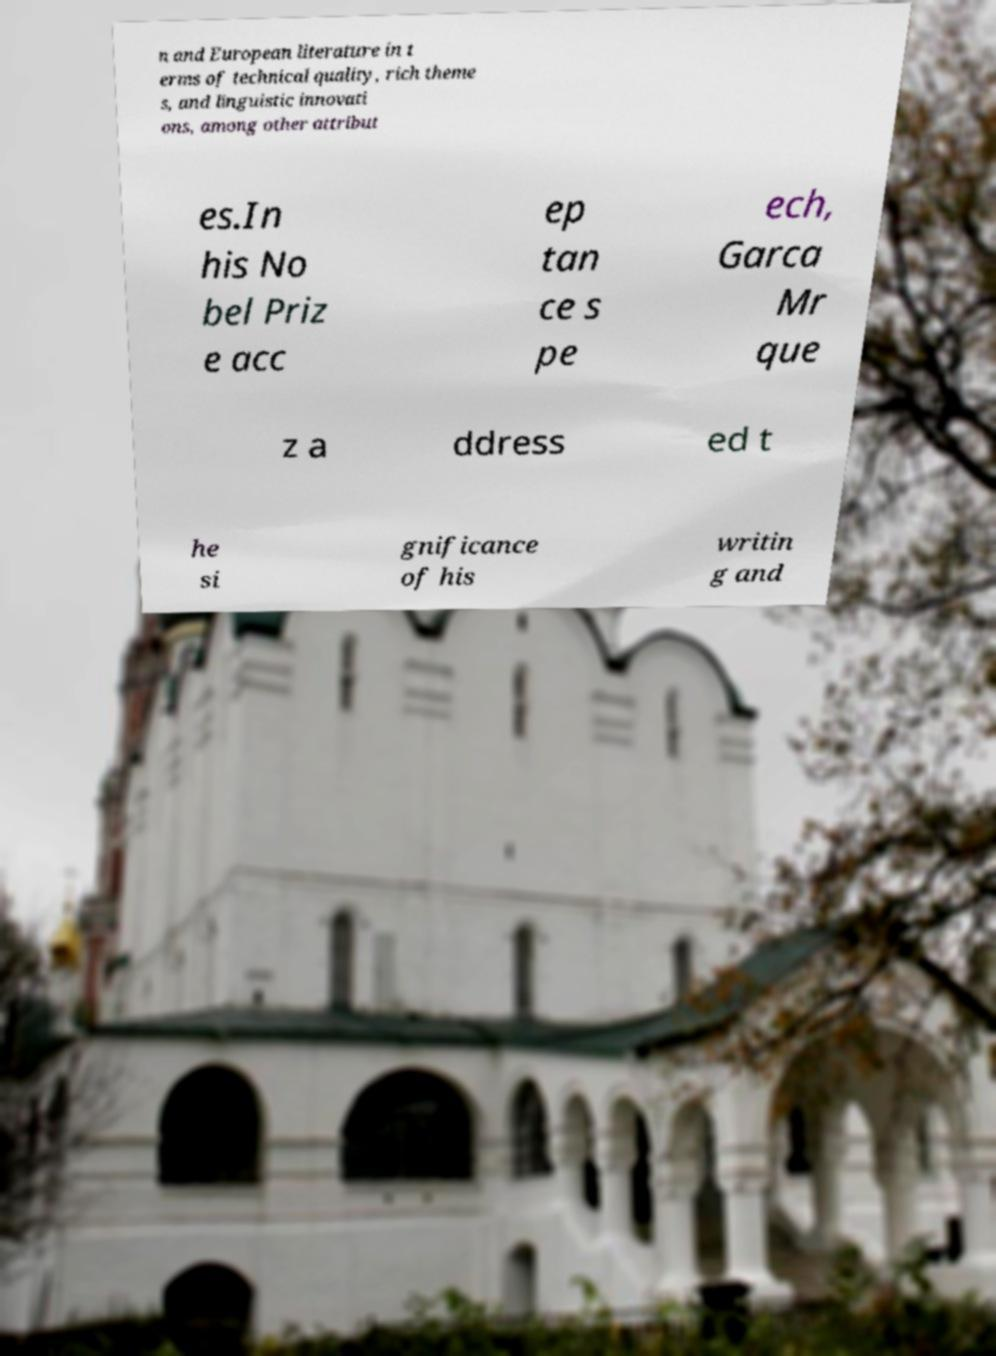I need the written content from this picture converted into text. Can you do that? n and European literature in t erms of technical quality, rich theme s, and linguistic innovati ons, among other attribut es.In his No bel Priz e acc ep tan ce s pe ech, Garca Mr que z a ddress ed t he si gnificance of his writin g and 